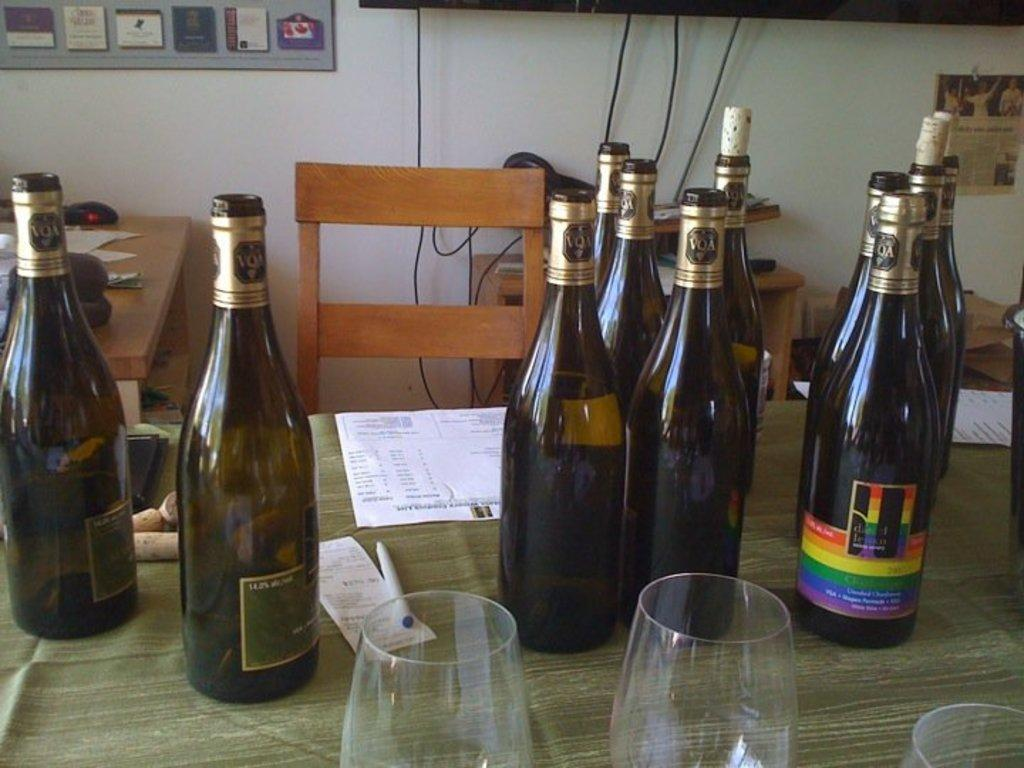What objects are on the table in the image? There are bottles, glasses, and paper on the table. Can you describe the bottles and glasses on the table? The bottles and glasses are likely used for holding liquids. What might the paper on the table be used for? The paper on the table might be used for writing, drawing, or covering something. How does the person get a haircut while sitting at the table in the image? There is no person getting a haircut in the image; it only shows bottles, glasses, and paper on the table. What type of drink is being served in the glasses in the image? The image does not provide enough information to determine the type of drink in the glasses. 